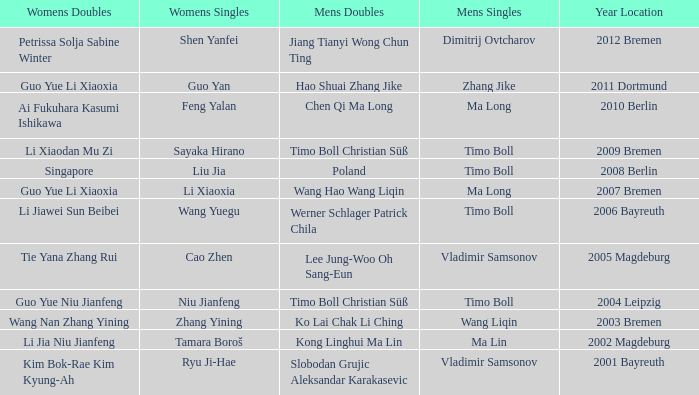Who won Womens Singles in the year that Ma Lin won Mens Singles? Tamara Boroš. 